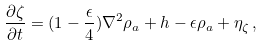<formula> <loc_0><loc_0><loc_500><loc_500>\frac { \partial \zeta } { \partial t } = ( 1 - \frac { \epsilon } { 4 } ) \nabla ^ { 2 } \rho _ { a } + h - \epsilon \rho _ { a } + \eta _ { \zeta } \, ,</formula> 